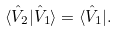Convert formula to latex. <formula><loc_0><loc_0><loc_500><loc_500>\langle \hat { V } _ { 2 } | \hat { V } _ { 1 } \rangle = \langle \hat { V } _ { 1 } | .</formula> 